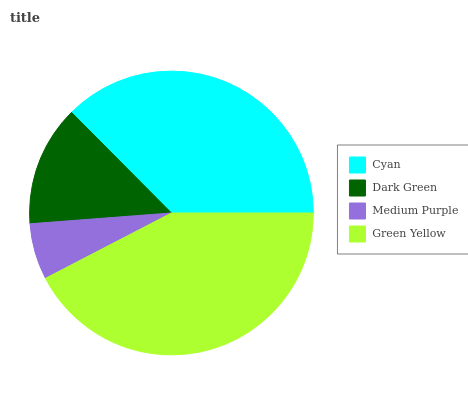Is Medium Purple the minimum?
Answer yes or no. Yes. Is Green Yellow the maximum?
Answer yes or no. Yes. Is Dark Green the minimum?
Answer yes or no. No. Is Dark Green the maximum?
Answer yes or no. No. Is Cyan greater than Dark Green?
Answer yes or no. Yes. Is Dark Green less than Cyan?
Answer yes or no. Yes. Is Dark Green greater than Cyan?
Answer yes or no. No. Is Cyan less than Dark Green?
Answer yes or no. No. Is Cyan the high median?
Answer yes or no. Yes. Is Dark Green the low median?
Answer yes or no. Yes. Is Green Yellow the high median?
Answer yes or no. No. Is Cyan the low median?
Answer yes or no. No. 